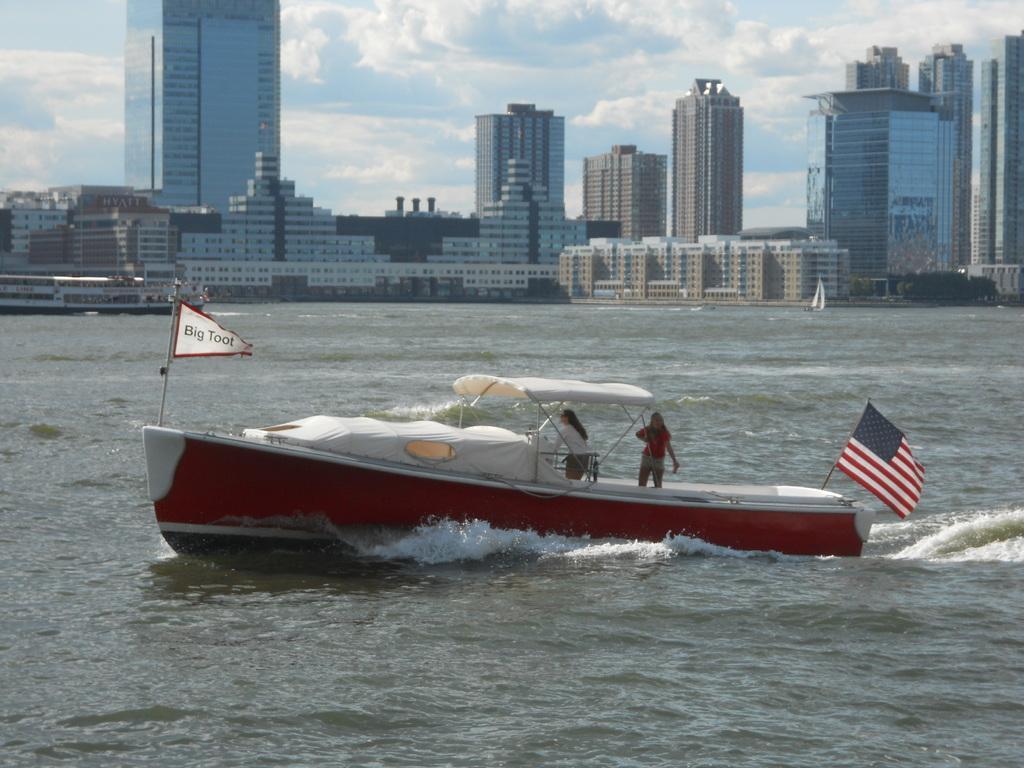Describe this image in one or two sentences. In this image in the center there is a Boat with the persons on it and there are flags on the boat which is sailing on water. In the background there are buildings and the sky is cloudy. 